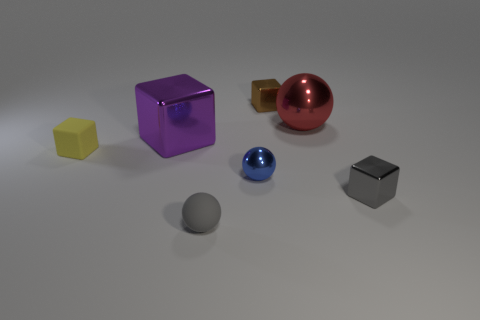Is there a large ball of the same color as the small matte ball?
Your answer should be compact. No. There is a metallic thing that is in front of the big purple shiny thing and on the left side of the brown shiny object; what is its shape?
Keep it short and to the point. Sphere. Are there an equal number of brown metal things that are in front of the purple cube and gray balls on the right side of the red shiny thing?
Give a very brief answer. Yes. What number of things are either red objects or matte things?
Your answer should be compact. 3. What color is the other object that is the same size as the red metal object?
Your answer should be very brief. Purple. What number of things are either small blocks that are right of the small blue metal ball or things in front of the red metal object?
Provide a succinct answer. 6. Is the number of small matte objects that are right of the purple object the same as the number of big gray matte cubes?
Your response must be concise. No. There is a red thing that is right of the tiny yellow matte thing; is it the same size as the rubber object that is on the right side of the large purple object?
Make the answer very short. No. What number of other things are the same size as the yellow object?
Your answer should be very brief. 4. Are there any big metallic objects that are left of the gray thing that is on the left side of the large thing behind the big purple cube?
Make the answer very short. Yes. 